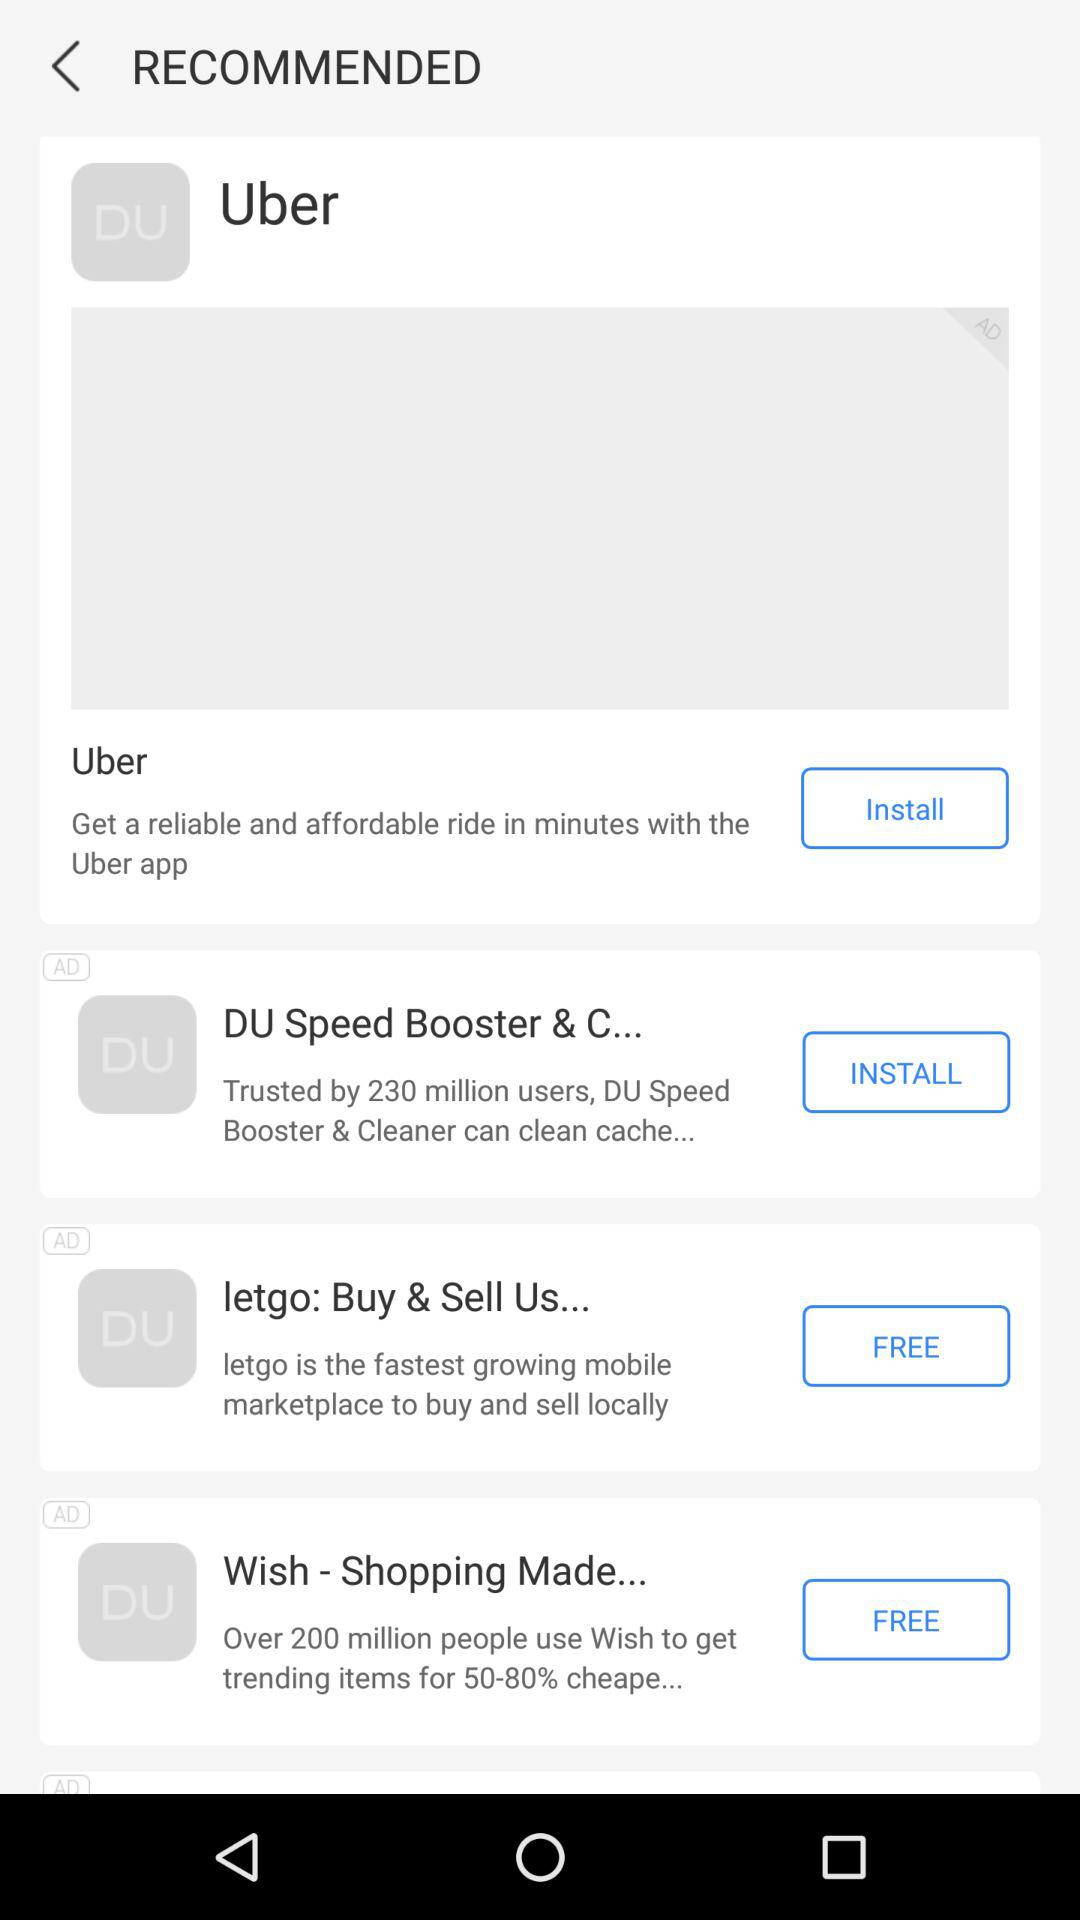Which application is installed?
When the provided information is insufficient, respond with <no answer>. <no answer> 